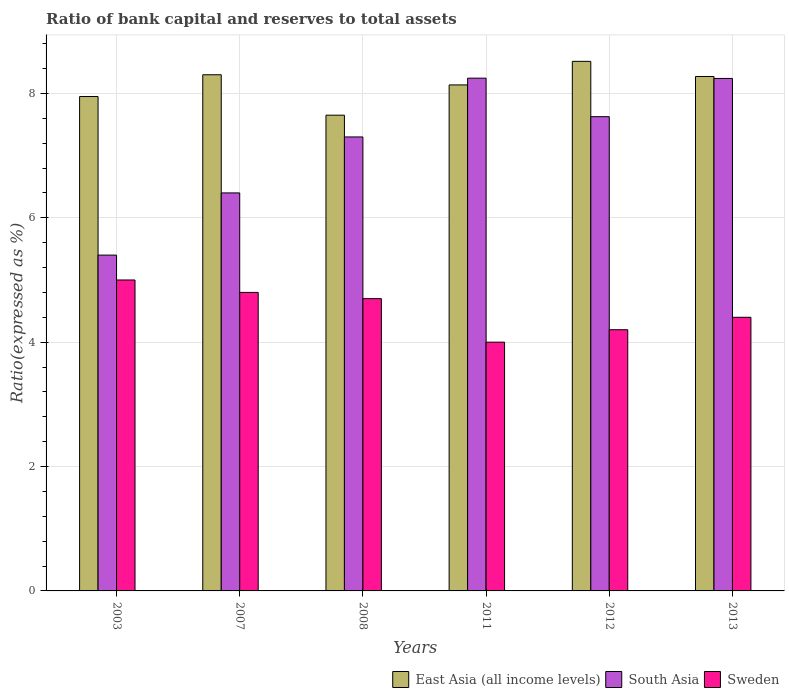How many different coloured bars are there?
Offer a very short reply. 3. How many groups of bars are there?
Ensure brevity in your answer.  6. Are the number of bars per tick equal to the number of legend labels?
Give a very brief answer. Yes. How many bars are there on the 3rd tick from the right?
Your answer should be compact. 3. What is the ratio of bank capital and reserves to total assets in South Asia in 2011?
Ensure brevity in your answer.  8.25. Across all years, what is the maximum ratio of bank capital and reserves to total assets in East Asia (all income levels)?
Provide a short and direct response. 8.52. Across all years, what is the minimum ratio of bank capital and reserves to total assets in Sweden?
Give a very brief answer. 4. In which year was the ratio of bank capital and reserves to total assets in Sweden maximum?
Your answer should be compact. 2003. In which year was the ratio of bank capital and reserves to total assets in East Asia (all income levels) minimum?
Provide a short and direct response. 2008. What is the total ratio of bank capital and reserves to total assets in East Asia (all income levels) in the graph?
Provide a succinct answer. 48.83. What is the difference between the ratio of bank capital and reserves to total assets in Sweden in 2003 and that in 2013?
Your response must be concise. 0.6. What is the difference between the ratio of bank capital and reserves to total assets in Sweden in 2011 and the ratio of bank capital and reserves to total assets in South Asia in 2008?
Provide a short and direct response. -3.3. What is the average ratio of bank capital and reserves to total assets in East Asia (all income levels) per year?
Your answer should be compact. 8.14. In the year 2013, what is the difference between the ratio of bank capital and reserves to total assets in Sweden and ratio of bank capital and reserves to total assets in South Asia?
Provide a succinct answer. -3.84. In how many years, is the ratio of bank capital and reserves to total assets in South Asia greater than 4.4 %?
Your response must be concise. 6. What is the ratio of the ratio of bank capital and reserves to total assets in East Asia (all income levels) in 2003 to that in 2008?
Offer a terse response. 1.04. What is the difference between the highest and the second highest ratio of bank capital and reserves to total assets in South Asia?
Your answer should be compact. 0. What is the difference between the highest and the lowest ratio of bank capital and reserves to total assets in East Asia (all income levels)?
Give a very brief answer. 0.87. In how many years, is the ratio of bank capital and reserves to total assets in Sweden greater than the average ratio of bank capital and reserves to total assets in Sweden taken over all years?
Provide a short and direct response. 3. Is the sum of the ratio of bank capital and reserves to total assets in Sweden in 2003 and 2008 greater than the maximum ratio of bank capital and reserves to total assets in South Asia across all years?
Provide a short and direct response. Yes. What does the 2nd bar from the left in 2011 represents?
Offer a terse response. South Asia. Is it the case that in every year, the sum of the ratio of bank capital and reserves to total assets in South Asia and ratio of bank capital and reserves to total assets in East Asia (all income levels) is greater than the ratio of bank capital and reserves to total assets in Sweden?
Make the answer very short. Yes. How many bars are there?
Your answer should be compact. 18. Are all the bars in the graph horizontal?
Provide a succinct answer. No. How many years are there in the graph?
Offer a very short reply. 6. What is the difference between two consecutive major ticks on the Y-axis?
Your answer should be very brief. 2. Does the graph contain any zero values?
Provide a short and direct response. No. How many legend labels are there?
Give a very brief answer. 3. How are the legend labels stacked?
Give a very brief answer. Horizontal. What is the title of the graph?
Give a very brief answer. Ratio of bank capital and reserves to total assets. Does "United Kingdom" appear as one of the legend labels in the graph?
Your response must be concise. No. What is the label or title of the Y-axis?
Give a very brief answer. Ratio(expressed as %). What is the Ratio(expressed as %) of East Asia (all income levels) in 2003?
Provide a succinct answer. 7.95. What is the Ratio(expressed as %) of East Asia (all income levels) in 2007?
Offer a very short reply. 8.3. What is the Ratio(expressed as %) of South Asia in 2007?
Your response must be concise. 6.4. What is the Ratio(expressed as %) of East Asia (all income levels) in 2008?
Provide a short and direct response. 7.65. What is the Ratio(expressed as %) of South Asia in 2008?
Make the answer very short. 7.3. What is the Ratio(expressed as %) of East Asia (all income levels) in 2011?
Keep it short and to the point. 8.14. What is the Ratio(expressed as %) in South Asia in 2011?
Offer a terse response. 8.25. What is the Ratio(expressed as %) of East Asia (all income levels) in 2012?
Your answer should be compact. 8.52. What is the Ratio(expressed as %) of South Asia in 2012?
Offer a very short reply. 7.63. What is the Ratio(expressed as %) in East Asia (all income levels) in 2013?
Provide a succinct answer. 8.27. What is the Ratio(expressed as %) of South Asia in 2013?
Provide a succinct answer. 8.24. What is the Ratio(expressed as %) in Sweden in 2013?
Provide a succinct answer. 4.4. Across all years, what is the maximum Ratio(expressed as %) of East Asia (all income levels)?
Offer a very short reply. 8.52. Across all years, what is the maximum Ratio(expressed as %) in South Asia?
Provide a short and direct response. 8.25. Across all years, what is the maximum Ratio(expressed as %) of Sweden?
Provide a succinct answer. 5. Across all years, what is the minimum Ratio(expressed as %) of East Asia (all income levels)?
Ensure brevity in your answer.  7.65. Across all years, what is the minimum Ratio(expressed as %) in South Asia?
Your answer should be compact. 5.4. Across all years, what is the minimum Ratio(expressed as %) in Sweden?
Offer a terse response. 4. What is the total Ratio(expressed as %) in East Asia (all income levels) in the graph?
Provide a succinct answer. 48.83. What is the total Ratio(expressed as %) in South Asia in the graph?
Make the answer very short. 43.21. What is the total Ratio(expressed as %) in Sweden in the graph?
Make the answer very short. 27.1. What is the difference between the Ratio(expressed as %) in East Asia (all income levels) in 2003 and that in 2007?
Keep it short and to the point. -0.35. What is the difference between the Ratio(expressed as %) in East Asia (all income levels) in 2003 and that in 2008?
Make the answer very short. 0.3. What is the difference between the Ratio(expressed as %) of South Asia in 2003 and that in 2008?
Ensure brevity in your answer.  -1.9. What is the difference between the Ratio(expressed as %) of Sweden in 2003 and that in 2008?
Offer a very short reply. 0.3. What is the difference between the Ratio(expressed as %) of East Asia (all income levels) in 2003 and that in 2011?
Offer a terse response. -0.19. What is the difference between the Ratio(expressed as %) in South Asia in 2003 and that in 2011?
Keep it short and to the point. -2.85. What is the difference between the Ratio(expressed as %) in Sweden in 2003 and that in 2011?
Give a very brief answer. 1. What is the difference between the Ratio(expressed as %) in East Asia (all income levels) in 2003 and that in 2012?
Your answer should be very brief. -0.57. What is the difference between the Ratio(expressed as %) in South Asia in 2003 and that in 2012?
Offer a terse response. -2.23. What is the difference between the Ratio(expressed as %) of East Asia (all income levels) in 2003 and that in 2013?
Offer a terse response. -0.32. What is the difference between the Ratio(expressed as %) in South Asia in 2003 and that in 2013?
Your answer should be compact. -2.84. What is the difference between the Ratio(expressed as %) of East Asia (all income levels) in 2007 and that in 2008?
Offer a very short reply. 0.65. What is the difference between the Ratio(expressed as %) of South Asia in 2007 and that in 2008?
Make the answer very short. -0.9. What is the difference between the Ratio(expressed as %) in East Asia (all income levels) in 2007 and that in 2011?
Make the answer very short. 0.16. What is the difference between the Ratio(expressed as %) of South Asia in 2007 and that in 2011?
Offer a terse response. -1.85. What is the difference between the Ratio(expressed as %) in Sweden in 2007 and that in 2011?
Make the answer very short. 0.8. What is the difference between the Ratio(expressed as %) of East Asia (all income levels) in 2007 and that in 2012?
Make the answer very short. -0.22. What is the difference between the Ratio(expressed as %) of South Asia in 2007 and that in 2012?
Provide a succinct answer. -1.23. What is the difference between the Ratio(expressed as %) of East Asia (all income levels) in 2007 and that in 2013?
Give a very brief answer. 0.03. What is the difference between the Ratio(expressed as %) of South Asia in 2007 and that in 2013?
Ensure brevity in your answer.  -1.84. What is the difference between the Ratio(expressed as %) in Sweden in 2007 and that in 2013?
Offer a terse response. 0.4. What is the difference between the Ratio(expressed as %) in East Asia (all income levels) in 2008 and that in 2011?
Ensure brevity in your answer.  -0.49. What is the difference between the Ratio(expressed as %) of South Asia in 2008 and that in 2011?
Your answer should be very brief. -0.95. What is the difference between the Ratio(expressed as %) in East Asia (all income levels) in 2008 and that in 2012?
Provide a short and direct response. -0.87. What is the difference between the Ratio(expressed as %) in South Asia in 2008 and that in 2012?
Offer a very short reply. -0.33. What is the difference between the Ratio(expressed as %) in East Asia (all income levels) in 2008 and that in 2013?
Make the answer very short. -0.62. What is the difference between the Ratio(expressed as %) of South Asia in 2008 and that in 2013?
Offer a terse response. -0.94. What is the difference between the Ratio(expressed as %) of Sweden in 2008 and that in 2013?
Offer a terse response. 0.3. What is the difference between the Ratio(expressed as %) of East Asia (all income levels) in 2011 and that in 2012?
Keep it short and to the point. -0.38. What is the difference between the Ratio(expressed as %) in South Asia in 2011 and that in 2012?
Offer a very short reply. 0.62. What is the difference between the Ratio(expressed as %) of Sweden in 2011 and that in 2012?
Ensure brevity in your answer.  -0.2. What is the difference between the Ratio(expressed as %) of East Asia (all income levels) in 2011 and that in 2013?
Make the answer very short. -0.14. What is the difference between the Ratio(expressed as %) of South Asia in 2011 and that in 2013?
Your answer should be compact. 0. What is the difference between the Ratio(expressed as %) of Sweden in 2011 and that in 2013?
Your answer should be compact. -0.4. What is the difference between the Ratio(expressed as %) of East Asia (all income levels) in 2012 and that in 2013?
Make the answer very short. 0.24. What is the difference between the Ratio(expressed as %) of South Asia in 2012 and that in 2013?
Your response must be concise. -0.61. What is the difference between the Ratio(expressed as %) in East Asia (all income levels) in 2003 and the Ratio(expressed as %) in South Asia in 2007?
Your answer should be very brief. 1.55. What is the difference between the Ratio(expressed as %) in East Asia (all income levels) in 2003 and the Ratio(expressed as %) in Sweden in 2007?
Your response must be concise. 3.15. What is the difference between the Ratio(expressed as %) of South Asia in 2003 and the Ratio(expressed as %) of Sweden in 2007?
Keep it short and to the point. 0.6. What is the difference between the Ratio(expressed as %) of East Asia (all income levels) in 2003 and the Ratio(expressed as %) of South Asia in 2008?
Keep it short and to the point. 0.65. What is the difference between the Ratio(expressed as %) of East Asia (all income levels) in 2003 and the Ratio(expressed as %) of Sweden in 2008?
Your answer should be very brief. 3.25. What is the difference between the Ratio(expressed as %) in East Asia (all income levels) in 2003 and the Ratio(expressed as %) in South Asia in 2011?
Offer a very short reply. -0.3. What is the difference between the Ratio(expressed as %) of East Asia (all income levels) in 2003 and the Ratio(expressed as %) of Sweden in 2011?
Provide a succinct answer. 3.95. What is the difference between the Ratio(expressed as %) in East Asia (all income levels) in 2003 and the Ratio(expressed as %) in South Asia in 2012?
Give a very brief answer. 0.32. What is the difference between the Ratio(expressed as %) of East Asia (all income levels) in 2003 and the Ratio(expressed as %) of Sweden in 2012?
Offer a very short reply. 3.75. What is the difference between the Ratio(expressed as %) in South Asia in 2003 and the Ratio(expressed as %) in Sweden in 2012?
Offer a very short reply. 1.2. What is the difference between the Ratio(expressed as %) of East Asia (all income levels) in 2003 and the Ratio(expressed as %) of South Asia in 2013?
Your answer should be compact. -0.29. What is the difference between the Ratio(expressed as %) of East Asia (all income levels) in 2003 and the Ratio(expressed as %) of Sweden in 2013?
Your response must be concise. 3.55. What is the difference between the Ratio(expressed as %) in South Asia in 2003 and the Ratio(expressed as %) in Sweden in 2013?
Keep it short and to the point. 1. What is the difference between the Ratio(expressed as %) of South Asia in 2007 and the Ratio(expressed as %) of Sweden in 2008?
Provide a short and direct response. 1.7. What is the difference between the Ratio(expressed as %) of East Asia (all income levels) in 2007 and the Ratio(expressed as %) of South Asia in 2011?
Your answer should be very brief. 0.05. What is the difference between the Ratio(expressed as %) in East Asia (all income levels) in 2007 and the Ratio(expressed as %) in South Asia in 2012?
Provide a short and direct response. 0.67. What is the difference between the Ratio(expressed as %) in East Asia (all income levels) in 2007 and the Ratio(expressed as %) in South Asia in 2013?
Make the answer very short. 0.06. What is the difference between the Ratio(expressed as %) in South Asia in 2007 and the Ratio(expressed as %) in Sweden in 2013?
Offer a terse response. 2. What is the difference between the Ratio(expressed as %) of East Asia (all income levels) in 2008 and the Ratio(expressed as %) of South Asia in 2011?
Make the answer very short. -0.6. What is the difference between the Ratio(expressed as %) of East Asia (all income levels) in 2008 and the Ratio(expressed as %) of Sweden in 2011?
Make the answer very short. 3.65. What is the difference between the Ratio(expressed as %) of South Asia in 2008 and the Ratio(expressed as %) of Sweden in 2011?
Offer a terse response. 3.3. What is the difference between the Ratio(expressed as %) of East Asia (all income levels) in 2008 and the Ratio(expressed as %) of South Asia in 2012?
Your response must be concise. 0.02. What is the difference between the Ratio(expressed as %) in East Asia (all income levels) in 2008 and the Ratio(expressed as %) in Sweden in 2012?
Offer a terse response. 3.45. What is the difference between the Ratio(expressed as %) in South Asia in 2008 and the Ratio(expressed as %) in Sweden in 2012?
Make the answer very short. 3.1. What is the difference between the Ratio(expressed as %) of East Asia (all income levels) in 2008 and the Ratio(expressed as %) of South Asia in 2013?
Your response must be concise. -0.59. What is the difference between the Ratio(expressed as %) in South Asia in 2008 and the Ratio(expressed as %) in Sweden in 2013?
Your response must be concise. 2.9. What is the difference between the Ratio(expressed as %) of East Asia (all income levels) in 2011 and the Ratio(expressed as %) of South Asia in 2012?
Provide a succinct answer. 0.51. What is the difference between the Ratio(expressed as %) in East Asia (all income levels) in 2011 and the Ratio(expressed as %) in Sweden in 2012?
Your answer should be compact. 3.94. What is the difference between the Ratio(expressed as %) of South Asia in 2011 and the Ratio(expressed as %) of Sweden in 2012?
Keep it short and to the point. 4.05. What is the difference between the Ratio(expressed as %) of East Asia (all income levels) in 2011 and the Ratio(expressed as %) of South Asia in 2013?
Your response must be concise. -0.1. What is the difference between the Ratio(expressed as %) in East Asia (all income levels) in 2011 and the Ratio(expressed as %) in Sweden in 2013?
Ensure brevity in your answer.  3.74. What is the difference between the Ratio(expressed as %) in South Asia in 2011 and the Ratio(expressed as %) in Sweden in 2013?
Your response must be concise. 3.85. What is the difference between the Ratio(expressed as %) in East Asia (all income levels) in 2012 and the Ratio(expressed as %) in South Asia in 2013?
Provide a short and direct response. 0.27. What is the difference between the Ratio(expressed as %) of East Asia (all income levels) in 2012 and the Ratio(expressed as %) of Sweden in 2013?
Keep it short and to the point. 4.12. What is the difference between the Ratio(expressed as %) in South Asia in 2012 and the Ratio(expressed as %) in Sweden in 2013?
Give a very brief answer. 3.23. What is the average Ratio(expressed as %) of East Asia (all income levels) per year?
Give a very brief answer. 8.14. What is the average Ratio(expressed as %) of South Asia per year?
Keep it short and to the point. 7.2. What is the average Ratio(expressed as %) in Sweden per year?
Offer a terse response. 4.52. In the year 2003, what is the difference between the Ratio(expressed as %) of East Asia (all income levels) and Ratio(expressed as %) of South Asia?
Ensure brevity in your answer.  2.55. In the year 2003, what is the difference between the Ratio(expressed as %) of East Asia (all income levels) and Ratio(expressed as %) of Sweden?
Keep it short and to the point. 2.95. In the year 2003, what is the difference between the Ratio(expressed as %) in South Asia and Ratio(expressed as %) in Sweden?
Make the answer very short. 0.4. In the year 2007, what is the difference between the Ratio(expressed as %) of East Asia (all income levels) and Ratio(expressed as %) of South Asia?
Ensure brevity in your answer.  1.9. In the year 2008, what is the difference between the Ratio(expressed as %) in East Asia (all income levels) and Ratio(expressed as %) in South Asia?
Give a very brief answer. 0.35. In the year 2008, what is the difference between the Ratio(expressed as %) of East Asia (all income levels) and Ratio(expressed as %) of Sweden?
Offer a very short reply. 2.95. In the year 2011, what is the difference between the Ratio(expressed as %) of East Asia (all income levels) and Ratio(expressed as %) of South Asia?
Your response must be concise. -0.11. In the year 2011, what is the difference between the Ratio(expressed as %) in East Asia (all income levels) and Ratio(expressed as %) in Sweden?
Ensure brevity in your answer.  4.14. In the year 2011, what is the difference between the Ratio(expressed as %) of South Asia and Ratio(expressed as %) of Sweden?
Your response must be concise. 4.25. In the year 2012, what is the difference between the Ratio(expressed as %) of East Asia (all income levels) and Ratio(expressed as %) of South Asia?
Your response must be concise. 0.89. In the year 2012, what is the difference between the Ratio(expressed as %) of East Asia (all income levels) and Ratio(expressed as %) of Sweden?
Your response must be concise. 4.32. In the year 2012, what is the difference between the Ratio(expressed as %) of South Asia and Ratio(expressed as %) of Sweden?
Your answer should be very brief. 3.43. In the year 2013, what is the difference between the Ratio(expressed as %) of East Asia (all income levels) and Ratio(expressed as %) of South Asia?
Make the answer very short. 0.03. In the year 2013, what is the difference between the Ratio(expressed as %) of East Asia (all income levels) and Ratio(expressed as %) of Sweden?
Keep it short and to the point. 3.87. In the year 2013, what is the difference between the Ratio(expressed as %) in South Asia and Ratio(expressed as %) in Sweden?
Offer a very short reply. 3.84. What is the ratio of the Ratio(expressed as %) of East Asia (all income levels) in 2003 to that in 2007?
Ensure brevity in your answer.  0.96. What is the ratio of the Ratio(expressed as %) in South Asia in 2003 to that in 2007?
Provide a succinct answer. 0.84. What is the ratio of the Ratio(expressed as %) in Sweden in 2003 to that in 2007?
Keep it short and to the point. 1.04. What is the ratio of the Ratio(expressed as %) of East Asia (all income levels) in 2003 to that in 2008?
Your answer should be very brief. 1.04. What is the ratio of the Ratio(expressed as %) of South Asia in 2003 to that in 2008?
Keep it short and to the point. 0.74. What is the ratio of the Ratio(expressed as %) of Sweden in 2003 to that in 2008?
Your answer should be compact. 1.06. What is the ratio of the Ratio(expressed as %) in East Asia (all income levels) in 2003 to that in 2011?
Provide a short and direct response. 0.98. What is the ratio of the Ratio(expressed as %) of South Asia in 2003 to that in 2011?
Offer a terse response. 0.65. What is the ratio of the Ratio(expressed as %) of Sweden in 2003 to that in 2011?
Ensure brevity in your answer.  1.25. What is the ratio of the Ratio(expressed as %) of East Asia (all income levels) in 2003 to that in 2012?
Provide a short and direct response. 0.93. What is the ratio of the Ratio(expressed as %) in South Asia in 2003 to that in 2012?
Offer a very short reply. 0.71. What is the ratio of the Ratio(expressed as %) in Sweden in 2003 to that in 2012?
Give a very brief answer. 1.19. What is the ratio of the Ratio(expressed as %) of South Asia in 2003 to that in 2013?
Make the answer very short. 0.66. What is the ratio of the Ratio(expressed as %) in Sweden in 2003 to that in 2013?
Provide a short and direct response. 1.14. What is the ratio of the Ratio(expressed as %) of East Asia (all income levels) in 2007 to that in 2008?
Ensure brevity in your answer.  1.08. What is the ratio of the Ratio(expressed as %) in South Asia in 2007 to that in 2008?
Provide a succinct answer. 0.88. What is the ratio of the Ratio(expressed as %) in Sweden in 2007 to that in 2008?
Provide a short and direct response. 1.02. What is the ratio of the Ratio(expressed as %) of East Asia (all income levels) in 2007 to that in 2011?
Provide a succinct answer. 1.02. What is the ratio of the Ratio(expressed as %) in South Asia in 2007 to that in 2011?
Make the answer very short. 0.78. What is the ratio of the Ratio(expressed as %) of Sweden in 2007 to that in 2011?
Your response must be concise. 1.2. What is the ratio of the Ratio(expressed as %) in East Asia (all income levels) in 2007 to that in 2012?
Make the answer very short. 0.97. What is the ratio of the Ratio(expressed as %) of South Asia in 2007 to that in 2012?
Offer a very short reply. 0.84. What is the ratio of the Ratio(expressed as %) in Sweden in 2007 to that in 2012?
Your answer should be compact. 1.14. What is the ratio of the Ratio(expressed as %) in South Asia in 2007 to that in 2013?
Your response must be concise. 0.78. What is the ratio of the Ratio(expressed as %) of East Asia (all income levels) in 2008 to that in 2011?
Give a very brief answer. 0.94. What is the ratio of the Ratio(expressed as %) of South Asia in 2008 to that in 2011?
Give a very brief answer. 0.89. What is the ratio of the Ratio(expressed as %) in Sweden in 2008 to that in 2011?
Keep it short and to the point. 1.18. What is the ratio of the Ratio(expressed as %) of East Asia (all income levels) in 2008 to that in 2012?
Your response must be concise. 0.9. What is the ratio of the Ratio(expressed as %) in South Asia in 2008 to that in 2012?
Provide a short and direct response. 0.96. What is the ratio of the Ratio(expressed as %) in Sweden in 2008 to that in 2012?
Your answer should be very brief. 1.12. What is the ratio of the Ratio(expressed as %) of East Asia (all income levels) in 2008 to that in 2013?
Provide a short and direct response. 0.92. What is the ratio of the Ratio(expressed as %) of South Asia in 2008 to that in 2013?
Make the answer very short. 0.89. What is the ratio of the Ratio(expressed as %) in Sweden in 2008 to that in 2013?
Provide a short and direct response. 1.07. What is the ratio of the Ratio(expressed as %) of East Asia (all income levels) in 2011 to that in 2012?
Keep it short and to the point. 0.96. What is the ratio of the Ratio(expressed as %) in South Asia in 2011 to that in 2012?
Ensure brevity in your answer.  1.08. What is the ratio of the Ratio(expressed as %) in Sweden in 2011 to that in 2012?
Keep it short and to the point. 0.95. What is the ratio of the Ratio(expressed as %) of East Asia (all income levels) in 2011 to that in 2013?
Make the answer very short. 0.98. What is the ratio of the Ratio(expressed as %) of East Asia (all income levels) in 2012 to that in 2013?
Make the answer very short. 1.03. What is the ratio of the Ratio(expressed as %) in South Asia in 2012 to that in 2013?
Offer a terse response. 0.93. What is the ratio of the Ratio(expressed as %) in Sweden in 2012 to that in 2013?
Offer a terse response. 0.95. What is the difference between the highest and the second highest Ratio(expressed as %) in East Asia (all income levels)?
Offer a very short reply. 0.22. What is the difference between the highest and the second highest Ratio(expressed as %) of South Asia?
Keep it short and to the point. 0. What is the difference between the highest and the second highest Ratio(expressed as %) of Sweden?
Give a very brief answer. 0.2. What is the difference between the highest and the lowest Ratio(expressed as %) of East Asia (all income levels)?
Ensure brevity in your answer.  0.87. What is the difference between the highest and the lowest Ratio(expressed as %) in South Asia?
Your answer should be very brief. 2.85. 